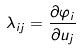Convert formula to latex. <formula><loc_0><loc_0><loc_500><loc_500>\lambda _ { i j } = \frac { \partial \varphi _ { i } } { \partial u _ { j } }</formula> 